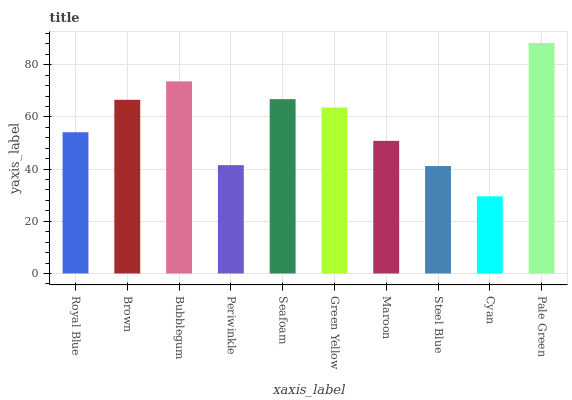Is Cyan the minimum?
Answer yes or no. Yes. Is Pale Green the maximum?
Answer yes or no. Yes. Is Brown the minimum?
Answer yes or no. No. Is Brown the maximum?
Answer yes or no. No. Is Brown greater than Royal Blue?
Answer yes or no. Yes. Is Royal Blue less than Brown?
Answer yes or no. Yes. Is Royal Blue greater than Brown?
Answer yes or no. No. Is Brown less than Royal Blue?
Answer yes or no. No. Is Green Yellow the high median?
Answer yes or no. Yes. Is Royal Blue the low median?
Answer yes or no. Yes. Is Periwinkle the high median?
Answer yes or no. No. Is Cyan the low median?
Answer yes or no. No. 